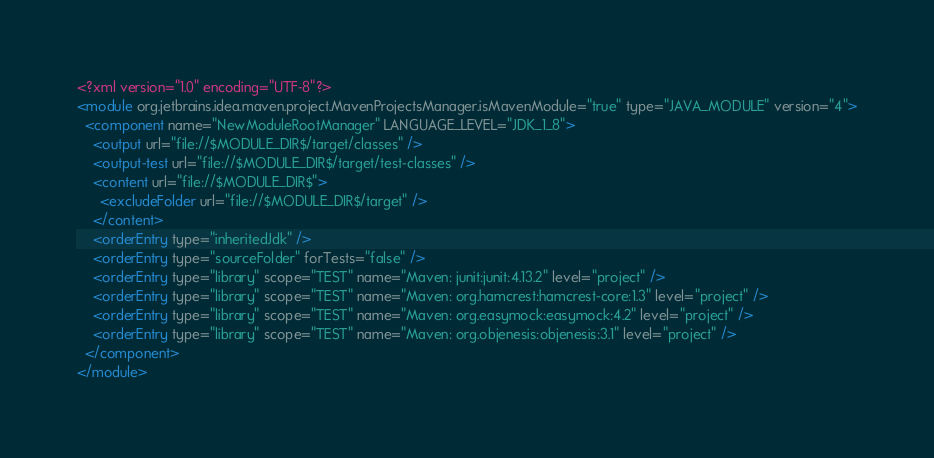Convert code to text. <code><loc_0><loc_0><loc_500><loc_500><_XML_><?xml version="1.0" encoding="UTF-8"?>
<module org.jetbrains.idea.maven.project.MavenProjectsManager.isMavenModule="true" type="JAVA_MODULE" version="4">
  <component name="NewModuleRootManager" LANGUAGE_LEVEL="JDK_1_8">
    <output url="file://$MODULE_DIR$/target/classes" />
    <output-test url="file://$MODULE_DIR$/target/test-classes" />
    <content url="file://$MODULE_DIR$">
      <excludeFolder url="file://$MODULE_DIR$/target" />
    </content>
    <orderEntry type="inheritedJdk" />
    <orderEntry type="sourceFolder" forTests="false" />
    <orderEntry type="library" scope="TEST" name="Maven: junit:junit:4.13.2" level="project" />
    <orderEntry type="library" scope="TEST" name="Maven: org.hamcrest:hamcrest-core:1.3" level="project" />
    <orderEntry type="library" scope="TEST" name="Maven: org.easymock:easymock:4.2" level="project" />
    <orderEntry type="library" scope="TEST" name="Maven: org.objenesis:objenesis:3.1" level="project" />
  </component>
</module></code> 